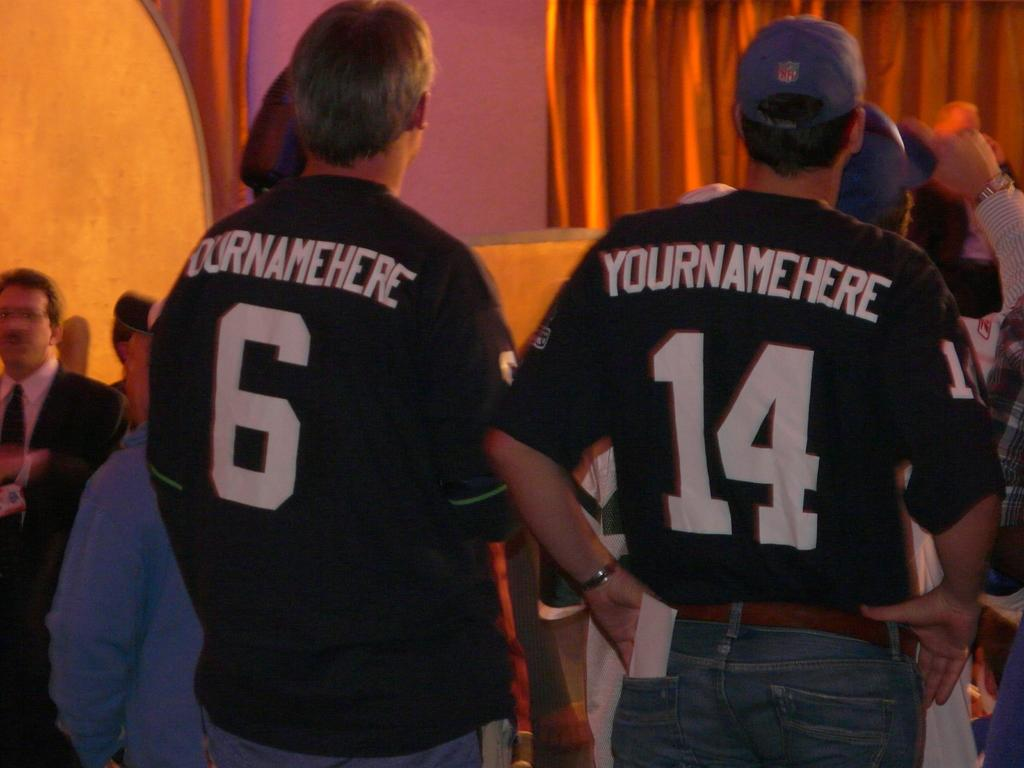<image>
Share a concise interpretation of the image provided. Two men wearing jerseys that say "yournamehere" on the back stand behind several other people. 